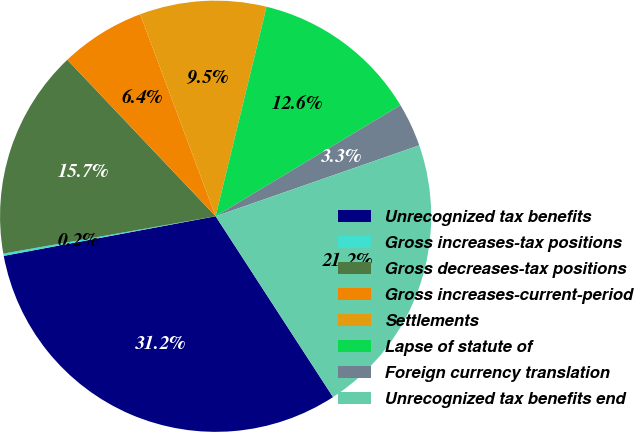<chart> <loc_0><loc_0><loc_500><loc_500><pie_chart><fcel>Unrecognized tax benefits<fcel>Gross increases-tax positions<fcel>Gross decreases-tax positions<fcel>Gross increases-current-period<fcel>Settlements<fcel>Lapse of statute of<fcel>Foreign currency translation<fcel>Unrecognized tax benefits end<nl><fcel>31.22%<fcel>0.17%<fcel>15.7%<fcel>6.38%<fcel>9.49%<fcel>12.59%<fcel>3.28%<fcel>21.17%<nl></chart> 